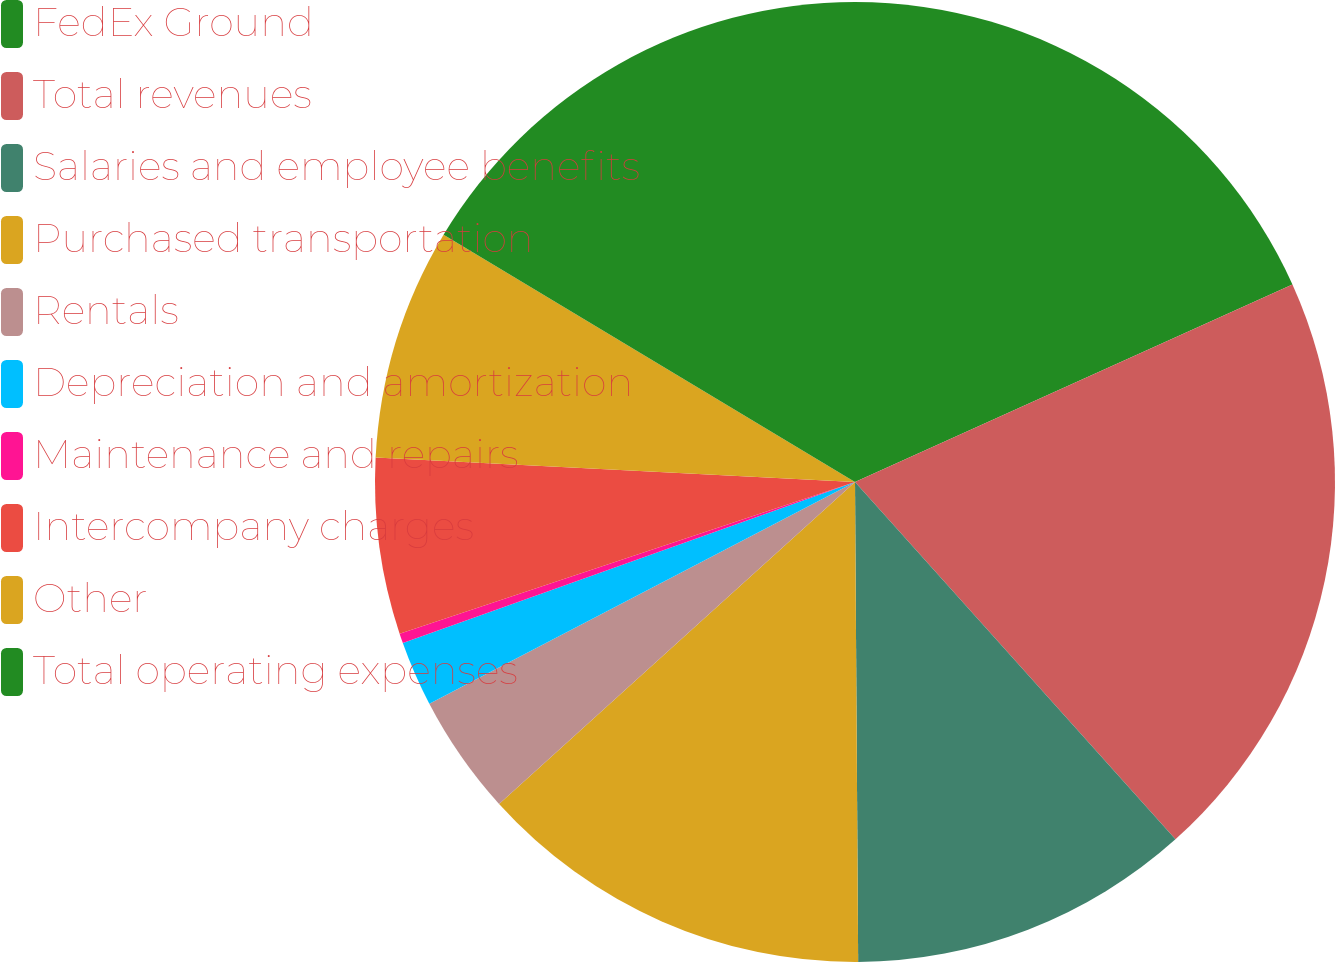Convert chart. <chart><loc_0><loc_0><loc_500><loc_500><pie_chart><fcel>FedEx Ground<fcel>Total revenues<fcel>Salaries and employee benefits<fcel>Purchased transportation<fcel>Rentals<fcel>Depreciation and amortization<fcel>Maintenance and repairs<fcel>Intercompany charges<fcel>Other<fcel>Total operating expenses<nl><fcel>18.25%<fcel>20.12%<fcel>11.53%<fcel>13.4%<fcel>4.06%<fcel>2.2%<fcel>0.33%<fcel>5.93%<fcel>7.8%<fcel>16.39%<nl></chart> 